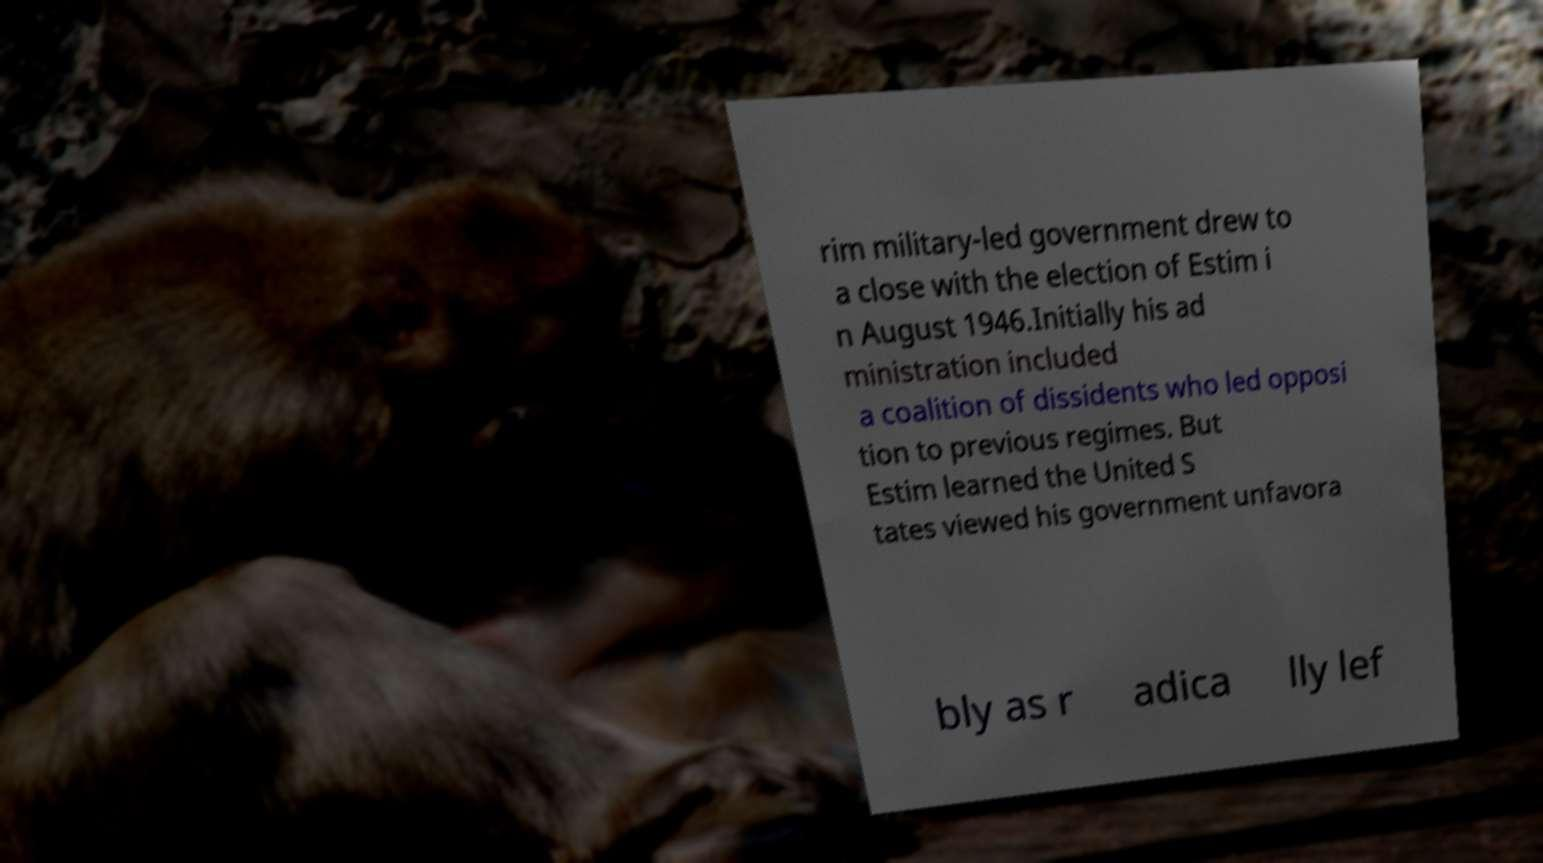Please identify and transcribe the text found in this image. rim military-led government drew to a close with the election of Estim i n August 1946.Initially his ad ministration included a coalition of dissidents who led opposi tion to previous regimes. But Estim learned the United S tates viewed his government unfavora bly as r adica lly lef 